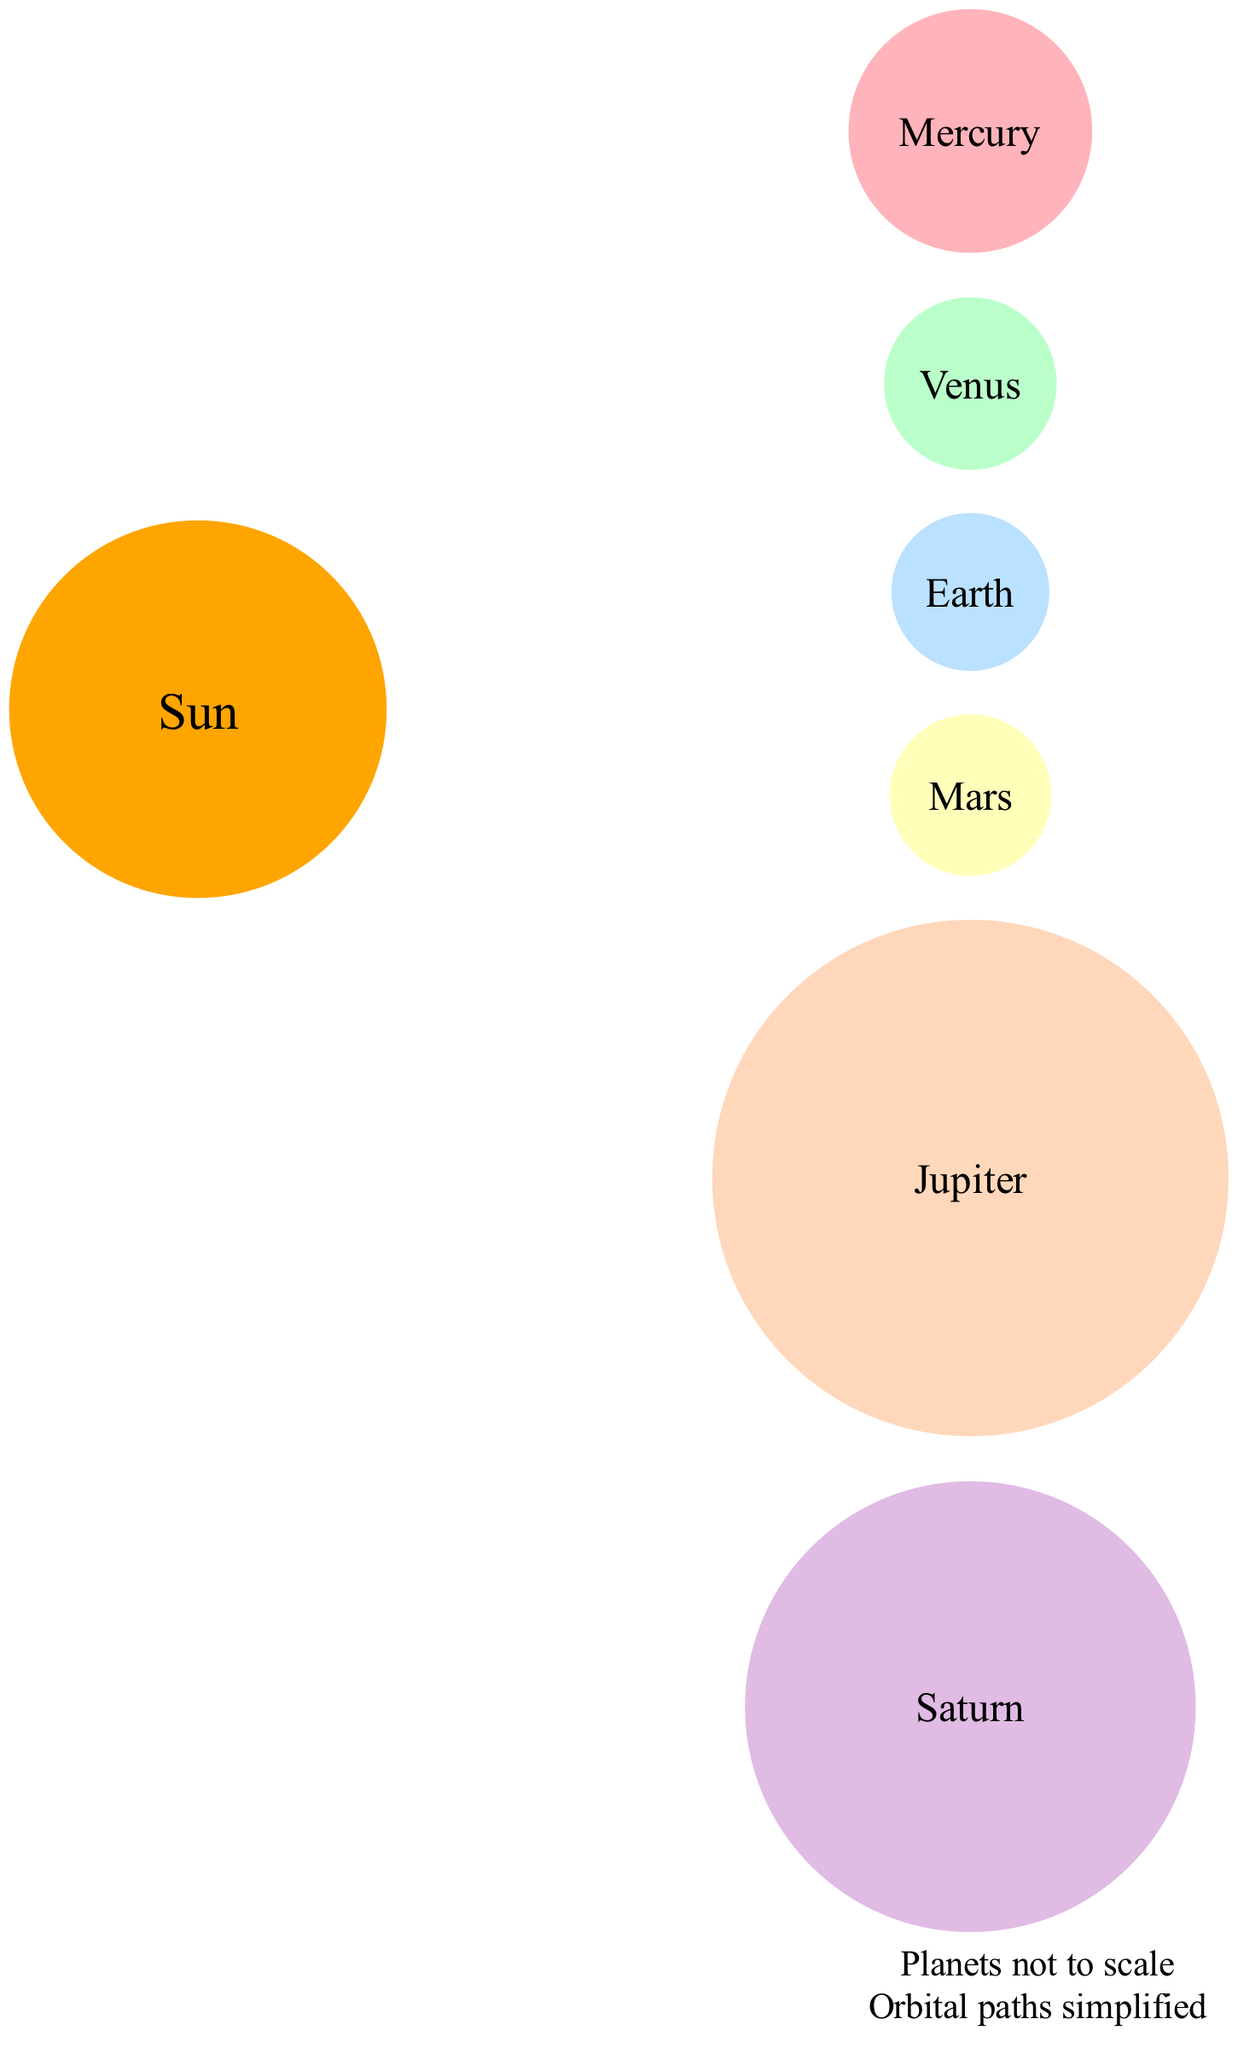What is the name of the central body in the solar system? The central body is identified in the diagram as the "Sun," which is also described as the central star of our solar system.
Answer: Sun How many planets are diagrammed in the solar system? By counting the distinct planets presented in the diagram, including Mercury, Venus, Earth, Mars, Jupiter, and Saturn, we find that there are six planets depicted.
Answer: 6 What is the orbital radius of Mars? The data given shows that Mars has an orbit radius of "227.9 million km," which is presented directly in the diagram.
Answer: 227.9 million km Which planet has the largest relative size? Among the planets listed in the diagram, Jupiter is shown to have the largest relative size at "11.2 Earth radii," clearly denoting it as the largest among all planets listed.
Answer: Jupiter If we were to sort the planets by orbit radius, which planet comes last? Based on the provided orbital radii, if sorted from closest to the Sun to farthest, Saturn has the largest orbital radius, thus it would come last.
Answer: Saturn What is the relative size of Earth? The diagram explicitly states that Earth has a relative size of "1 Earth radius," which can be seen as a standard reference for comparison with other planets.
Answer: 1 Earth radius Which planet has an orbit radius closest to 108.2 million km? By examining the orbital radius of the planets, Venus has an orbit radius of "108.2 million km," making it the closest to this measurement.
Answer: Venus What additional information does the diagram provide about the nature of the planets? The annotations in the diagram indicate that "Planets not to scale" and "Orbital paths simplified," conveying crucial information about how the diagram should be interpreted.
Answer: Planets not to scale and Orbital paths simplified Which planet is the second closest to the Sun? After analyzing the orbital radii, Venus is the second closest planet to the Sun, following Mercury, based on their respective distances.
Answer: Venus 